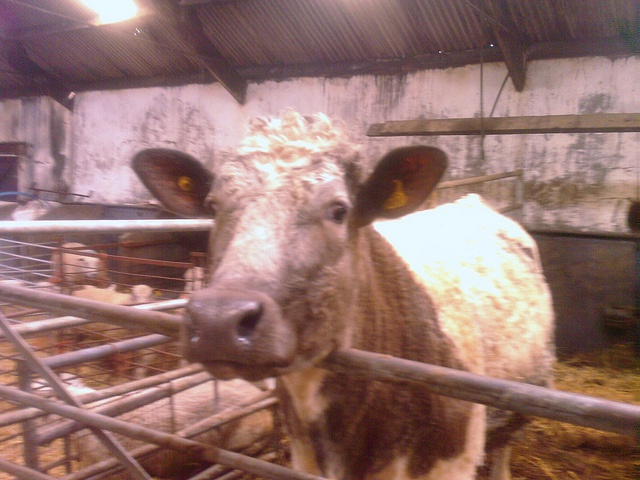Describe the objects in this image and their specific colors. I can see cow in purple, maroon, white, gray, and lightpink tones, sheep in purple, lightpink, gray, maroon, and brown tones, sheep in purple, lightpink, tan, and brown tones, and sheep in purple, lightpink, brown, and salmon tones in this image. 